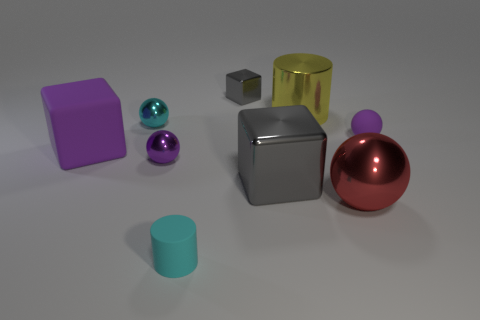Subtract all balls. How many objects are left? 5 Add 4 big yellow metallic cylinders. How many big yellow metallic cylinders are left? 5 Add 4 big cubes. How many big cubes exist? 6 Subtract 0 gray cylinders. How many objects are left? 9 Subtract all big purple blocks. Subtract all big metal things. How many objects are left? 5 